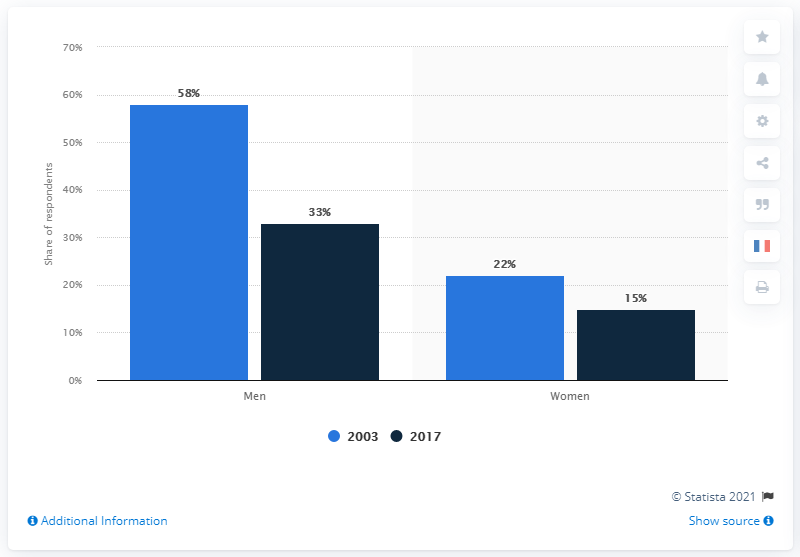Mention a couple of crucial points in this snapshot. In 2003, teenagers consumed less pornography. 